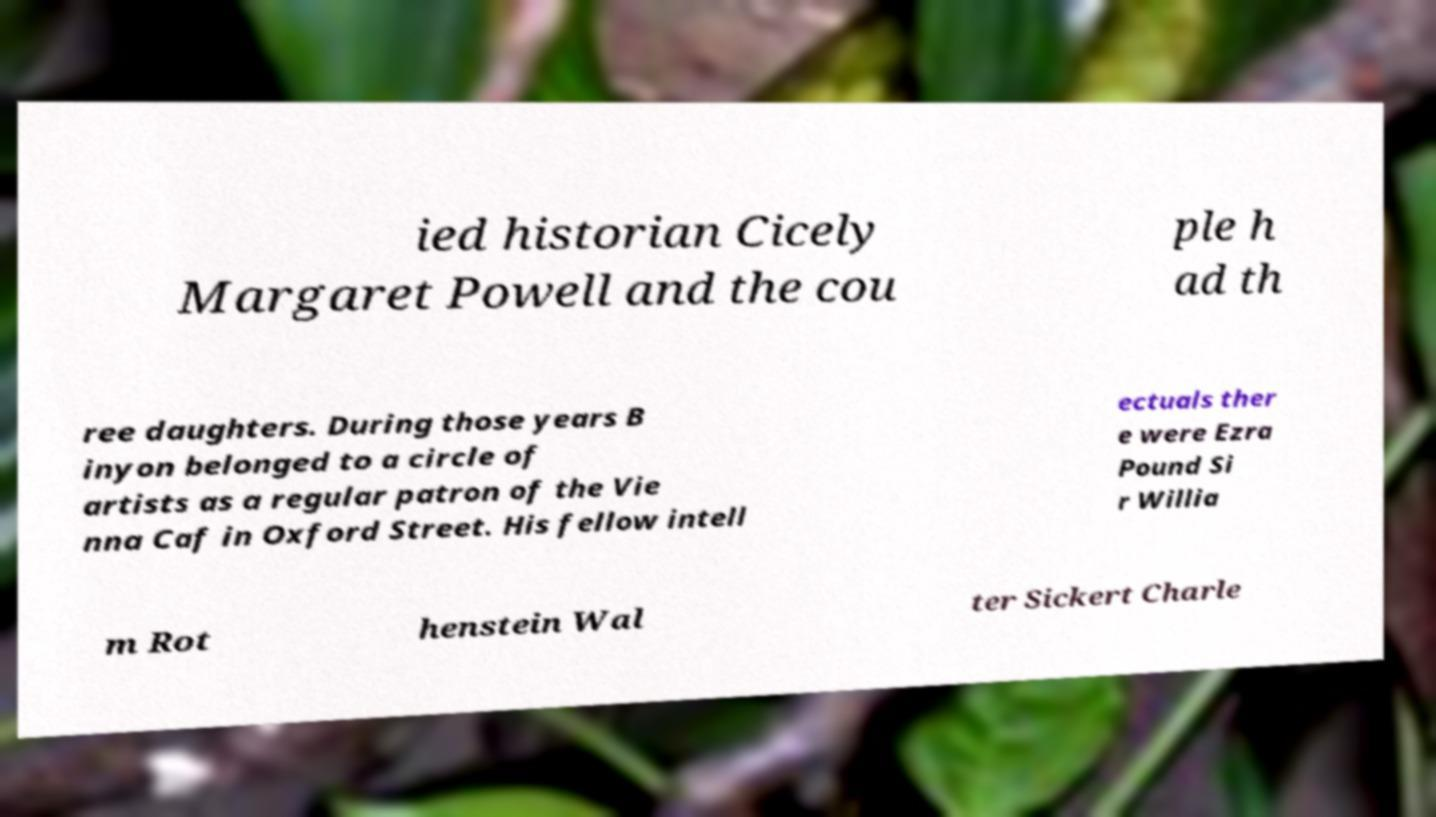Please identify and transcribe the text found in this image. ied historian Cicely Margaret Powell and the cou ple h ad th ree daughters. During those years B inyon belonged to a circle of artists as a regular patron of the Vie nna Caf in Oxford Street. His fellow intell ectuals ther e were Ezra Pound Si r Willia m Rot henstein Wal ter Sickert Charle 